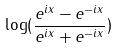Convert formula to latex. <formula><loc_0><loc_0><loc_500><loc_500>\log ( \frac { e ^ { i x } - e ^ { - i x } } { e ^ { i x } + e ^ { - i x } } )</formula> 